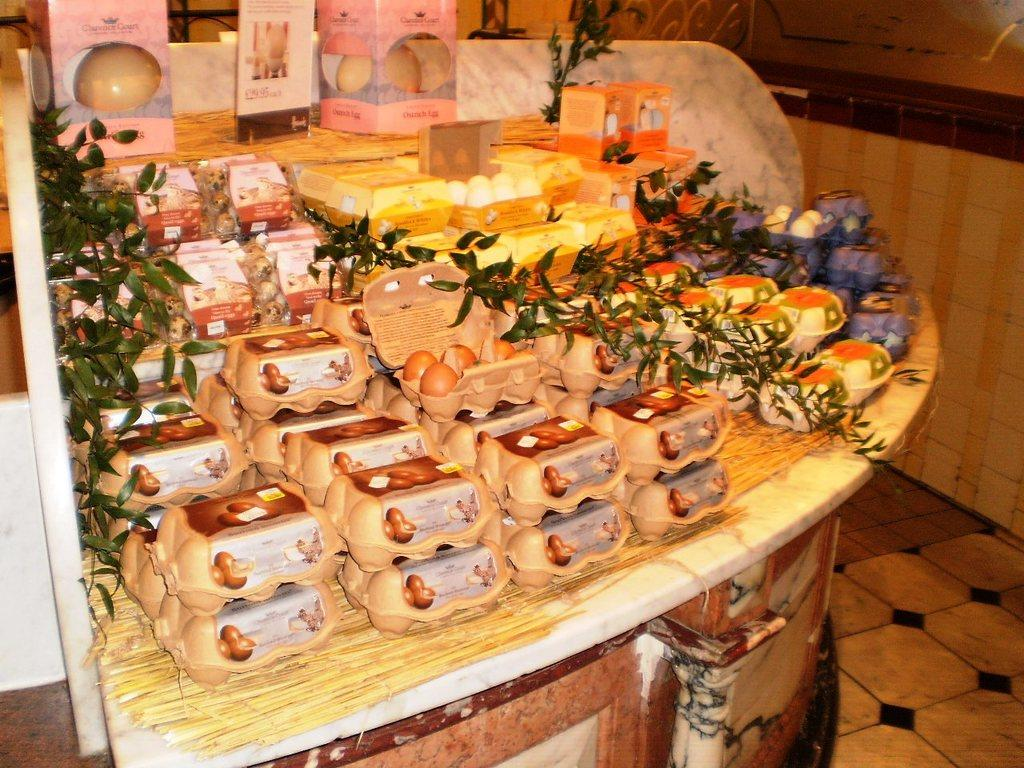What is the main subject of the image? The main subject of the image is egg trays. Where are the egg trays located on the desk? The egg trays are in the center of the circular desk. What else can be seen on the desk besides the egg trays? There are branches on the desk. What type of song is being played on the clocks in the image? There are no clocks present in the image, so it is not possible to determine what type of song might be playing. 